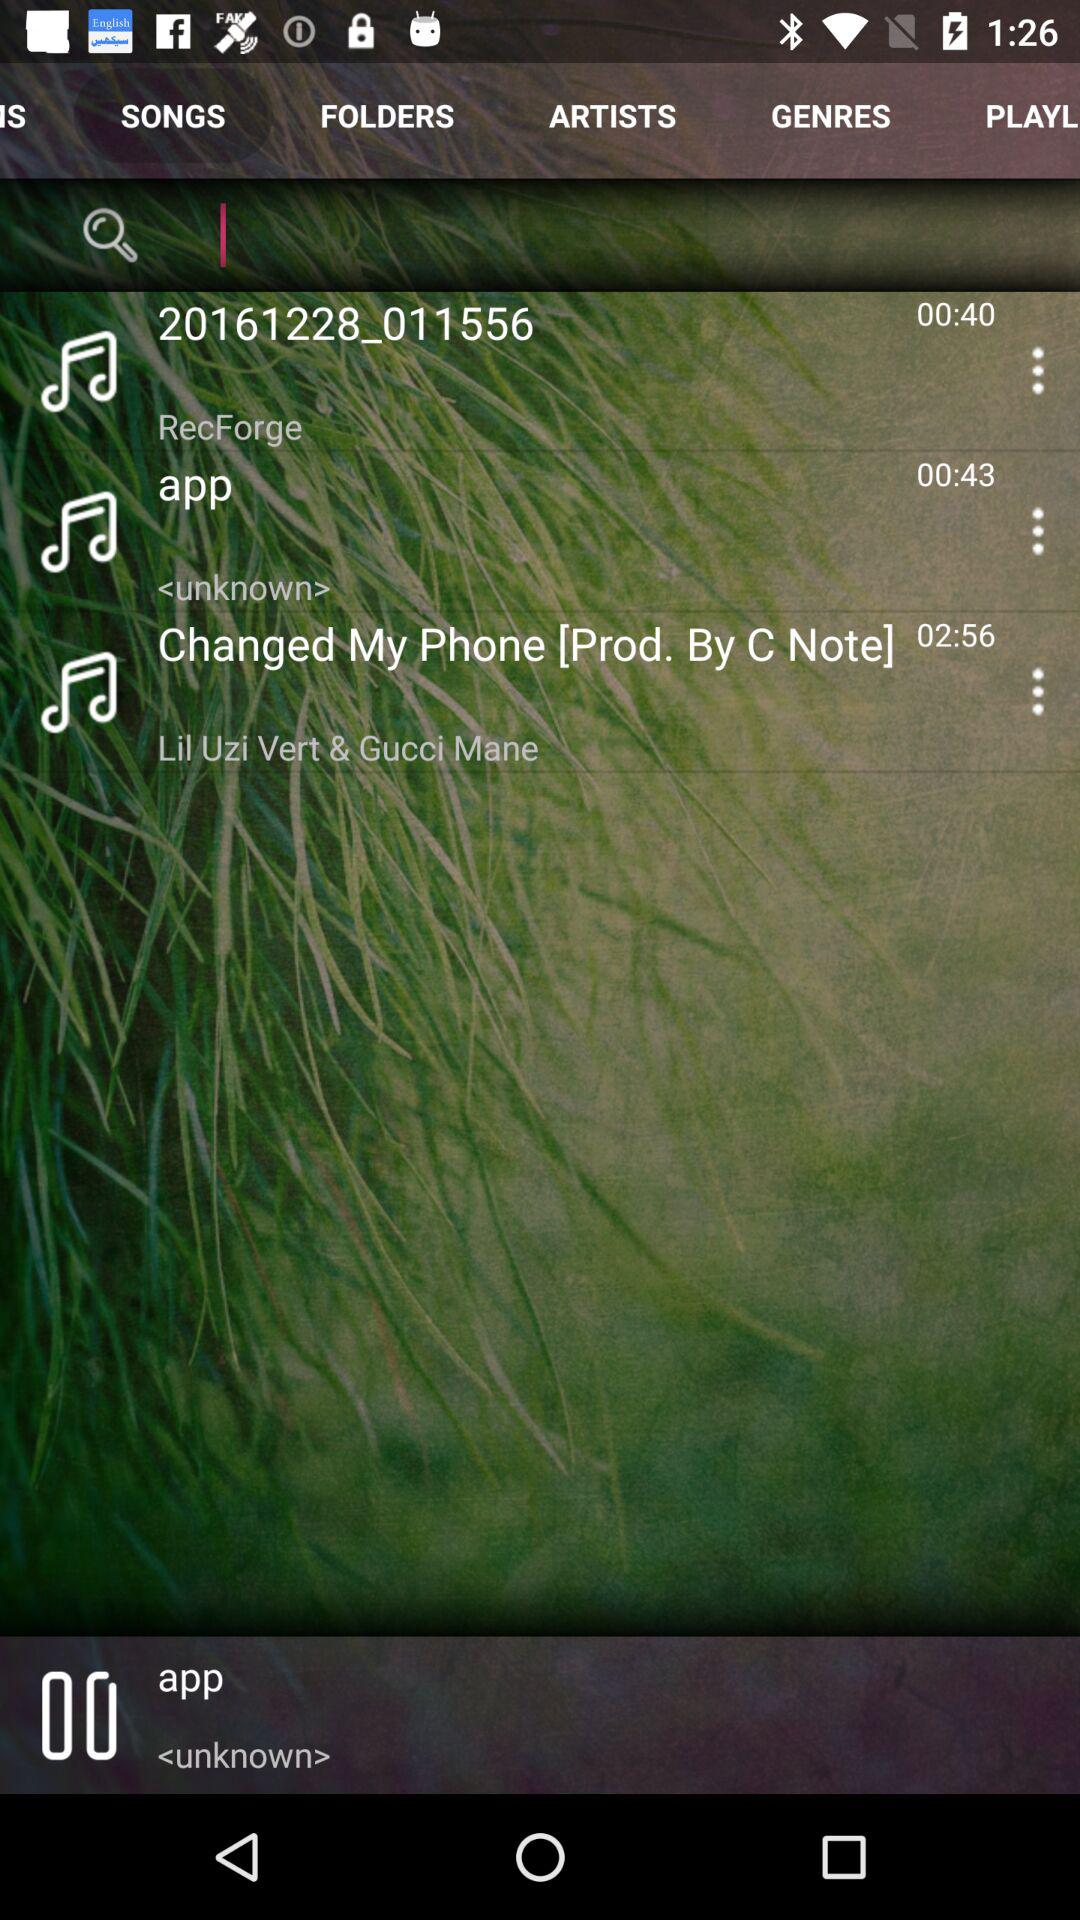What is the duration of the app song? The duration is 43 seconds. 